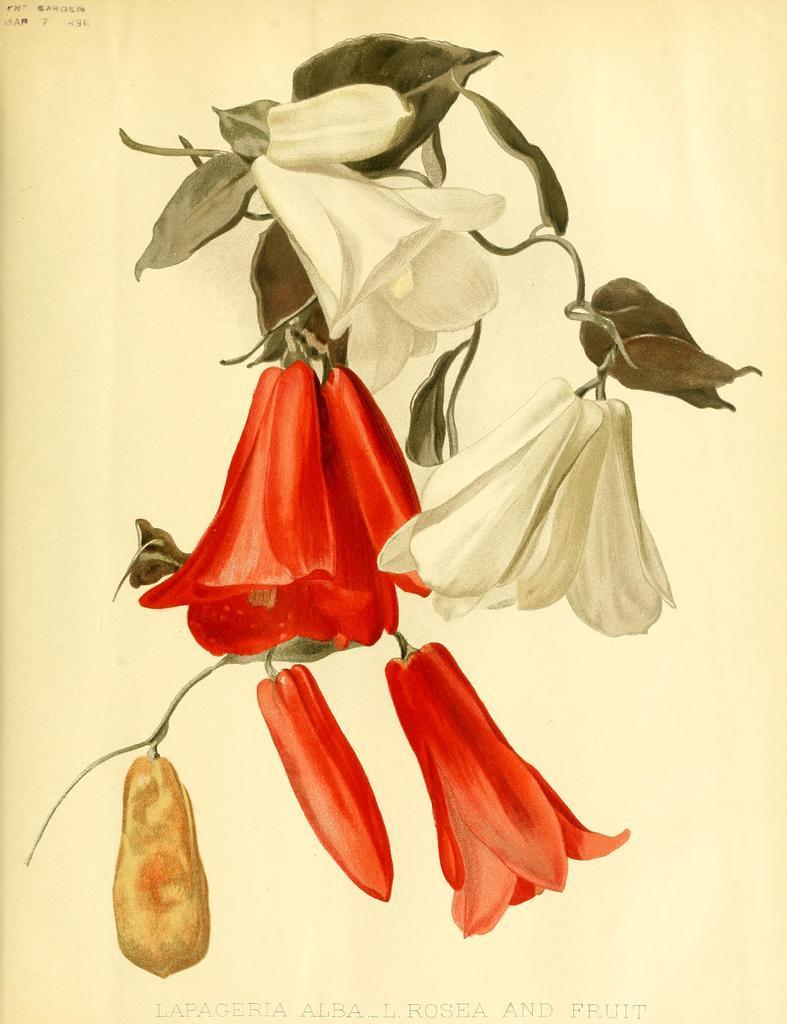In one or two sentences, can you explain what this image depicts? In this picture we can see white and red flowers drawing seen in the image. 